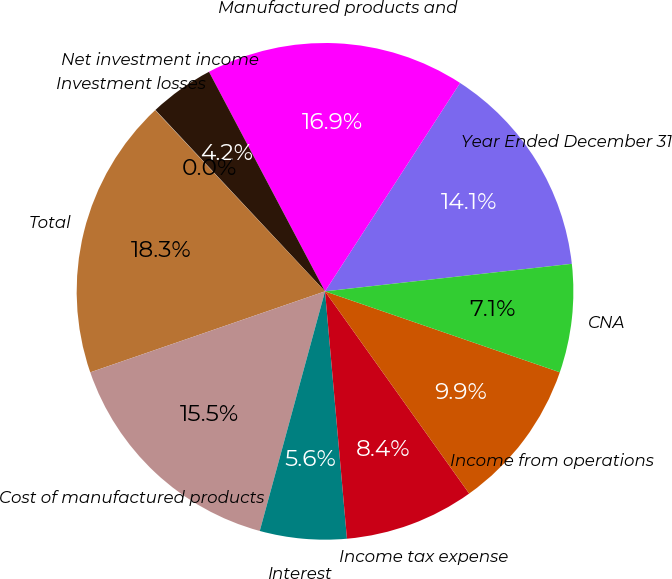Convert chart to OTSL. <chart><loc_0><loc_0><loc_500><loc_500><pie_chart><fcel>Year Ended December 31<fcel>Manufactured products and<fcel>Net investment income<fcel>Investment losses<fcel>Total<fcel>Cost of manufactured products<fcel>Interest<fcel>Income tax expense<fcel>Income from operations<fcel>CNA<nl><fcel>14.08%<fcel>16.89%<fcel>4.23%<fcel>0.02%<fcel>18.3%<fcel>15.48%<fcel>5.64%<fcel>8.45%<fcel>9.86%<fcel>7.05%<nl></chart> 